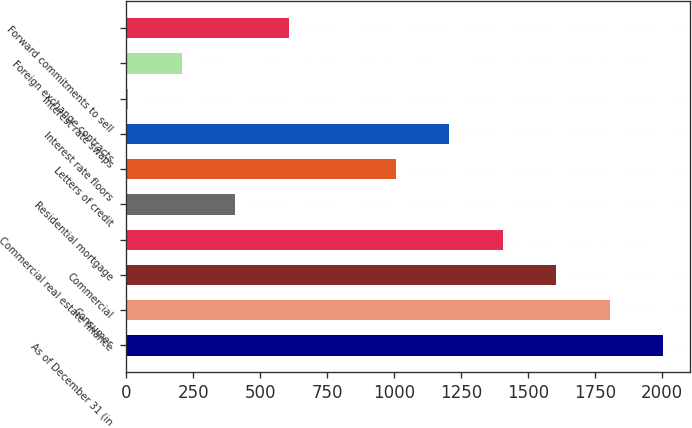Convert chart to OTSL. <chart><loc_0><loc_0><loc_500><loc_500><bar_chart><fcel>As of December 31 (in<fcel>Consumer<fcel>Commercial<fcel>Commercial real estate finance<fcel>Residential mortgage<fcel>Letters of credit<fcel>Interest rate floors<fcel>Interest rate swaps<fcel>Foreign exchange contracts<fcel>Forward commitments to sell<nl><fcel>2006<fcel>1806.09<fcel>1606.18<fcel>1406.27<fcel>406.72<fcel>1006.45<fcel>1206.36<fcel>6.9<fcel>206.81<fcel>606.63<nl></chart> 